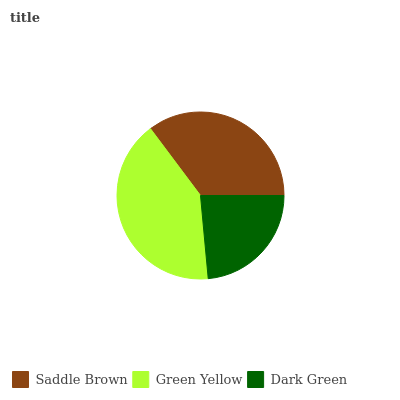Is Dark Green the minimum?
Answer yes or no. Yes. Is Green Yellow the maximum?
Answer yes or no. Yes. Is Green Yellow the minimum?
Answer yes or no. No. Is Dark Green the maximum?
Answer yes or no. No. Is Green Yellow greater than Dark Green?
Answer yes or no. Yes. Is Dark Green less than Green Yellow?
Answer yes or no. Yes. Is Dark Green greater than Green Yellow?
Answer yes or no. No. Is Green Yellow less than Dark Green?
Answer yes or no. No. Is Saddle Brown the high median?
Answer yes or no. Yes. Is Saddle Brown the low median?
Answer yes or no. Yes. Is Dark Green the high median?
Answer yes or no. No. Is Dark Green the low median?
Answer yes or no. No. 